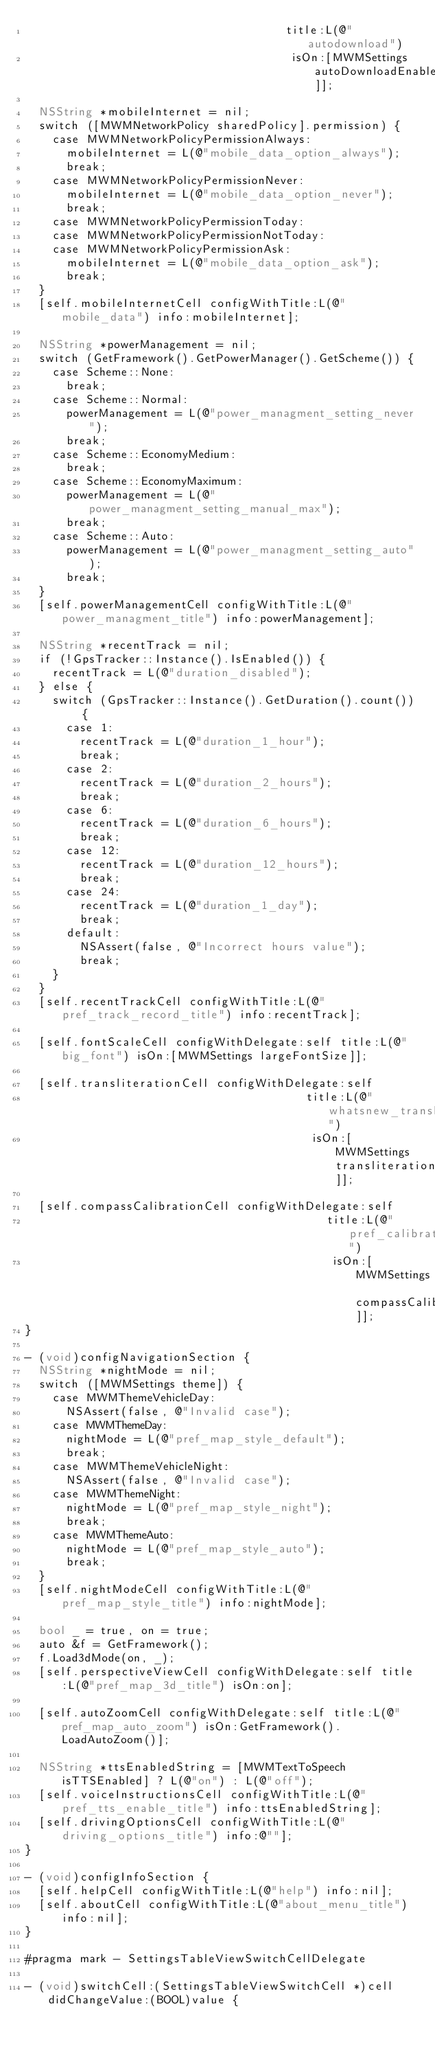Convert code to text. <code><loc_0><loc_0><loc_500><loc_500><_ObjectiveC_>                                      title:L(@"autodownload")
                                       isOn:[MWMSettings autoDownloadEnabled]];

  NSString *mobileInternet = nil;
  switch ([MWMNetworkPolicy sharedPolicy].permission) {
    case MWMNetworkPolicyPermissionAlways:
      mobileInternet = L(@"mobile_data_option_always");
      break;
    case MWMNetworkPolicyPermissionNever:
      mobileInternet = L(@"mobile_data_option_never");
      break;
    case MWMNetworkPolicyPermissionToday:
    case MWMNetworkPolicyPermissionNotToday:
    case MWMNetworkPolicyPermissionAsk:
      mobileInternet = L(@"mobile_data_option_ask");
      break;
  }
  [self.mobileInternetCell configWithTitle:L(@"mobile_data") info:mobileInternet];

  NSString *powerManagement = nil;
  switch (GetFramework().GetPowerManager().GetScheme()) {
    case Scheme::None:
      break;
    case Scheme::Normal:
      powerManagement = L(@"power_managment_setting_never");
      break;
    case Scheme::EconomyMedium:
      break;
    case Scheme::EconomyMaximum:
      powerManagement = L(@"power_managment_setting_manual_max");
      break;
    case Scheme::Auto:
      powerManagement = L(@"power_managment_setting_auto");
      break;
  }
  [self.powerManagementCell configWithTitle:L(@"power_managment_title") info:powerManagement];

  NSString *recentTrack = nil;
  if (!GpsTracker::Instance().IsEnabled()) {
    recentTrack = L(@"duration_disabled");
  } else {
    switch (GpsTracker::Instance().GetDuration().count()) {
      case 1:
        recentTrack = L(@"duration_1_hour");
        break;
      case 2:
        recentTrack = L(@"duration_2_hours");
        break;
      case 6:
        recentTrack = L(@"duration_6_hours");
        break;
      case 12:
        recentTrack = L(@"duration_12_hours");
        break;
      case 24:
        recentTrack = L(@"duration_1_day");
        break;
      default:
        NSAssert(false, @"Incorrect hours value");
        break;
    }
  }
  [self.recentTrackCell configWithTitle:L(@"pref_track_record_title") info:recentTrack];

  [self.fontScaleCell configWithDelegate:self title:L(@"big_font") isOn:[MWMSettings largeFontSize]];

  [self.transliterationCell configWithDelegate:self
                                         title:L(@"whatsnew_transliteration_title")
                                          isOn:[MWMSettings transliteration]];

  [self.compassCalibrationCell configWithDelegate:self
                                            title:L(@"pref_calibration_title")
                                             isOn:[MWMSettings compassCalibrationEnabled]];
}

- (void)configNavigationSection {
  NSString *nightMode = nil;
  switch ([MWMSettings theme]) {
    case MWMThemeVehicleDay:
      NSAssert(false, @"Invalid case");
    case MWMThemeDay:
      nightMode = L(@"pref_map_style_default");
      break;
    case MWMThemeVehicleNight:
      NSAssert(false, @"Invalid case");
    case MWMThemeNight:
      nightMode = L(@"pref_map_style_night");
      break;
    case MWMThemeAuto:
      nightMode = L(@"pref_map_style_auto");
      break;
  }
  [self.nightModeCell configWithTitle:L(@"pref_map_style_title") info:nightMode];

  bool _ = true, on = true;
  auto &f = GetFramework();
  f.Load3dMode(on, _);
  [self.perspectiveViewCell configWithDelegate:self title:L(@"pref_map_3d_title") isOn:on];

  [self.autoZoomCell configWithDelegate:self title:L(@"pref_map_auto_zoom") isOn:GetFramework().LoadAutoZoom()];

  NSString *ttsEnabledString = [MWMTextToSpeech isTTSEnabled] ? L(@"on") : L(@"off");
  [self.voiceInstructionsCell configWithTitle:L(@"pref_tts_enable_title") info:ttsEnabledString];
  [self.drivingOptionsCell configWithTitle:L(@"driving_options_title") info:@""];
}

- (void)configInfoSection {
  [self.helpCell configWithTitle:L(@"help") info:nil];
  [self.aboutCell configWithTitle:L(@"about_menu_title") info:nil];
}

#pragma mark - SettingsTableViewSwitchCellDelegate

- (void)switchCell:(SettingsTableViewSwitchCell *)cell didChangeValue:(BOOL)value {</code> 